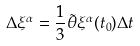<formula> <loc_0><loc_0><loc_500><loc_500>\Delta \xi ^ { \alpha } = \frac { 1 } { 3 } \tilde { \theta } \xi ^ { \alpha } ( t _ { 0 } ) \Delta t</formula> 